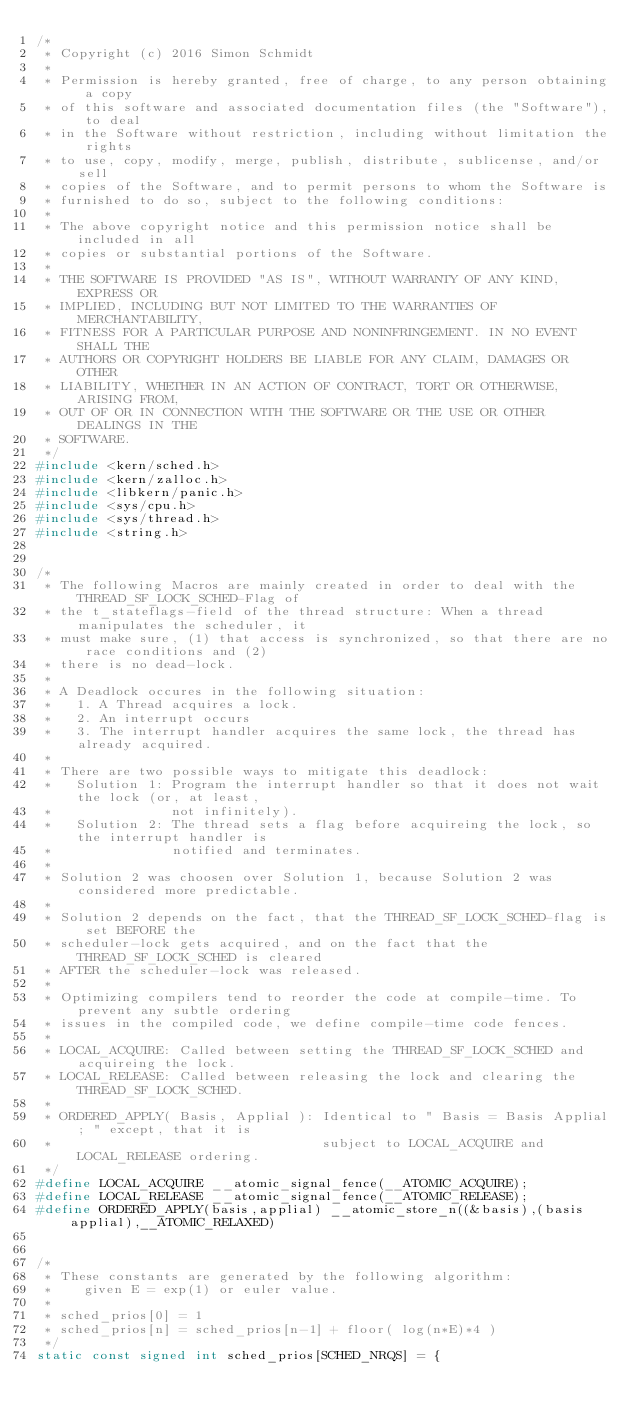Convert code to text. <code><loc_0><loc_0><loc_500><loc_500><_C_>/*
 * Copyright (c) 2016 Simon Schmidt
 * 
 * Permission is hereby granted, free of charge, to any person obtaining a copy
 * of this software and associated documentation files (the "Software"), to deal
 * in the Software without restriction, including without limitation the rights
 * to use, copy, modify, merge, publish, distribute, sublicense, and/or sell
 * copies of the Software, and to permit persons to whom the Software is
 * furnished to do so, subject to the following conditions:
 * 
 * The above copyright notice and this permission notice shall be included in all
 * copies or substantial portions of the Software.
 * 
 * THE SOFTWARE IS PROVIDED "AS IS", WITHOUT WARRANTY OF ANY KIND, EXPRESS OR
 * IMPLIED, INCLUDING BUT NOT LIMITED TO THE WARRANTIES OF MERCHANTABILITY,
 * FITNESS FOR A PARTICULAR PURPOSE AND NONINFRINGEMENT. IN NO EVENT SHALL THE
 * AUTHORS OR COPYRIGHT HOLDERS BE LIABLE FOR ANY CLAIM, DAMAGES OR OTHER
 * LIABILITY, WHETHER IN AN ACTION OF CONTRACT, TORT OR OTHERWISE, ARISING FROM,
 * OUT OF OR IN CONNECTION WITH THE SOFTWARE OR THE USE OR OTHER DEALINGS IN THE
 * SOFTWARE.
 */
#include <kern/sched.h>
#include <kern/zalloc.h>
#include <libkern/panic.h>
#include <sys/cpu.h>
#include <sys/thread.h>
#include <string.h>


/*
 * The following Macros are mainly created in order to deal with the THREAD_SF_LOCK_SCHED-Flag of
 * the t_stateflags-field of the thread structure: When a thread manipulates the scheduler, it
 * must make sure, (1) that access is synchronized, so that there are no race conditions and (2)
 * there is no dead-lock.
 *
 * A Deadlock occures in the following situation:
 *   1. A Thread acquires a lock.
 *   2. An interrupt occurs
 *   3. The interrupt handler acquires the same lock, the thread has already acquired.
 *
 * There are two possible ways to mitigate this deadlock:
 *   Solution 1: Program the interrupt handler so that it does not wait the lock (or, at least,
 *               not infinitely).
 *   Solution 2: The thread sets a flag before acquireing the lock, so the interrupt handler is
 *               notified and terminates.
 *
 * Solution 2 was choosen over Solution 1, because Solution 2 was considered more predictable.
 *
 * Solution 2 depends on the fact, that the THREAD_SF_LOCK_SCHED-flag is set BEFORE the
 * scheduler-lock gets acquired, and on the fact that the THREAD_SF_LOCK_SCHED is cleared
 * AFTER the scheduler-lock was released.
 *
 * Optimizing compilers tend to reorder the code at compile-time. To prevent any subtle ordering
 * issues in the compiled code, we define compile-time code fences.
 *
 * LOCAL_ACQUIRE: Called between setting the THREAD_SF_LOCK_SCHED and acquireing the lock.
 * LOCAL_RELEASE: Called between releasing the lock and clearing the THREAD_SF_LOCK_SCHED.
 *
 * ORDERED_APPLY( Basis, Applial ): Identical to " Basis = Basis Applial; " except, that it is
 *                                  subject to LOCAL_ACQUIRE and LOCAL_RELEASE ordering.
 */
#define LOCAL_ACQUIRE __atomic_signal_fence(__ATOMIC_ACQUIRE);
#define LOCAL_RELEASE __atomic_signal_fence(__ATOMIC_RELEASE);
#define ORDERED_APPLY(basis,applial) __atomic_store_n((&basis),(basis applial),__ATOMIC_RELAXED)


/*
 * These constants are generated by the following algorithm:
 *    given E = exp(1) or euler value.
 *
 * sched_prios[0] = 1
 * sched_prios[n] = sched_prios[n-1] + floor( log(n*E)*4 )
 */
static const signed int sched_prios[SCHED_NRQS] = {</code> 